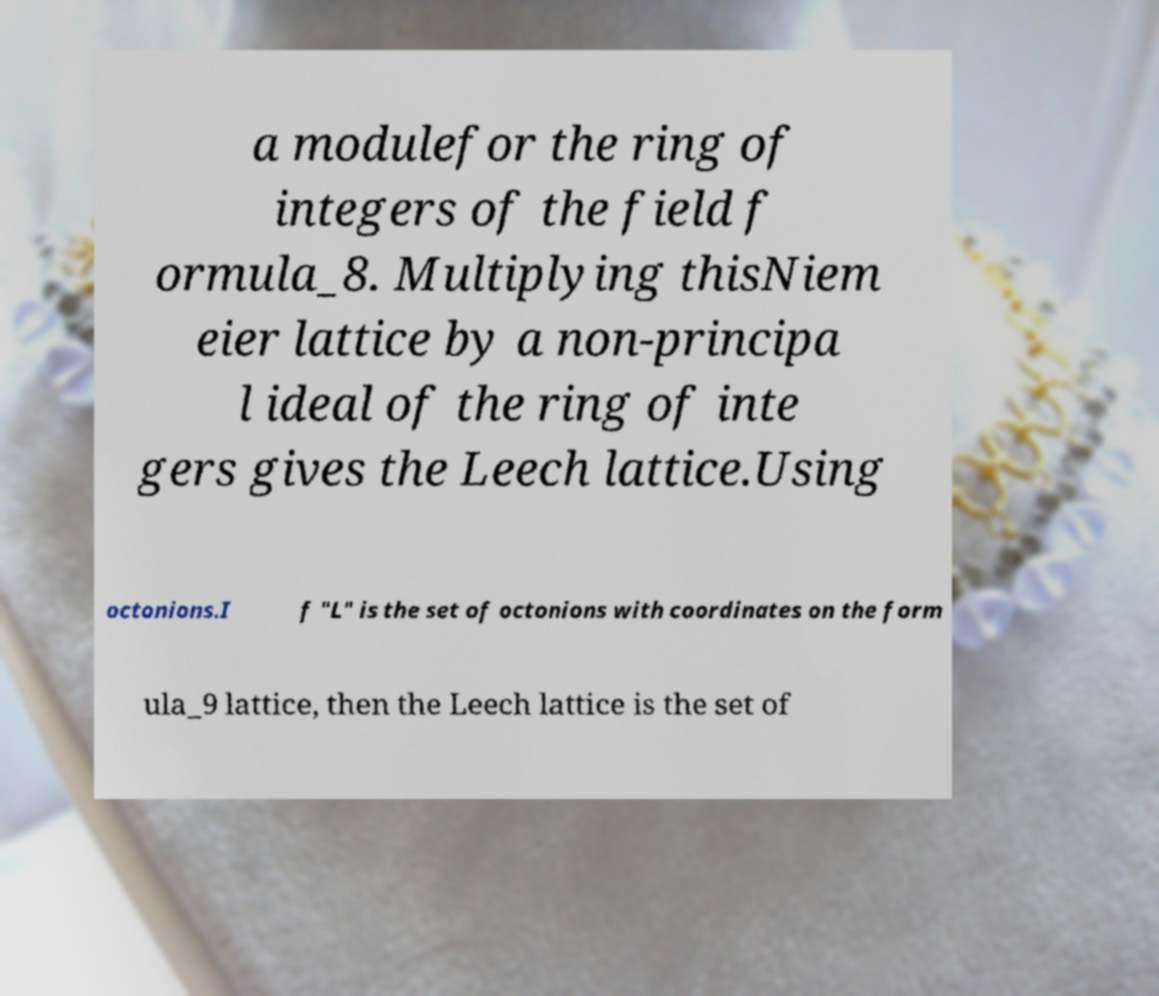There's text embedded in this image that I need extracted. Can you transcribe it verbatim? a modulefor the ring of integers of the field f ormula_8. Multiplying thisNiem eier lattice by a non-principa l ideal of the ring of inte gers gives the Leech lattice.Using octonions.I f "L" is the set of octonions with coordinates on the form ula_9 lattice, then the Leech lattice is the set of 